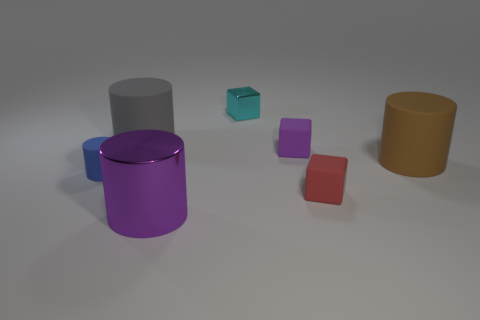There is a cube that is the same color as the large metallic cylinder; what size is it?
Give a very brief answer. Small. Do the rubber cylinder in front of the big brown rubber object and the rubber cube that is on the left side of the small red cube have the same size?
Keep it short and to the point. Yes. How many objects are big purple blocks or blue rubber objects?
Your response must be concise. 1. The big brown object has what shape?
Keep it short and to the point. Cylinder. What is the size of the brown object that is the same shape as the gray rubber thing?
Give a very brief answer. Large. There is a cylinder right of the small matte cube that is left of the tiny red matte block; what size is it?
Your response must be concise. Large. Are there an equal number of red matte objects behind the blue cylinder and small green shiny spheres?
Offer a very short reply. Yes. What number of other things are the same color as the tiny metal object?
Offer a terse response. 0. Is the number of rubber objects that are to the right of the gray rubber object less than the number of cylinders?
Your answer should be compact. Yes. Are there any cyan metallic blocks of the same size as the purple shiny thing?
Offer a terse response. No. 